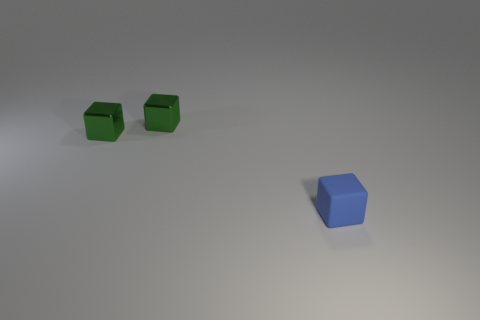What number of green metallic things have the same size as the blue thing?
Your response must be concise. 2. Are there any small matte objects of the same color as the rubber block?
Ensure brevity in your answer.  No. What is the color of the rubber cube?
Provide a succinct answer. Blue. Are there fewer small blue rubber cubes in front of the blue matte cube than big yellow balls?
Offer a very short reply. No. Are any green metallic blocks visible?
Give a very brief answer. Yes. How many other objects are the same shape as the blue thing?
Provide a succinct answer. 2. What number of balls are either green shiny objects or small matte objects?
Your response must be concise. 0. Is there any other thing that has the same material as the blue cube?
Provide a succinct answer. No. How many other objects are the same size as the blue rubber object?
Provide a succinct answer. 2. What number of green things are either small cylinders or metal things?
Ensure brevity in your answer.  2. 